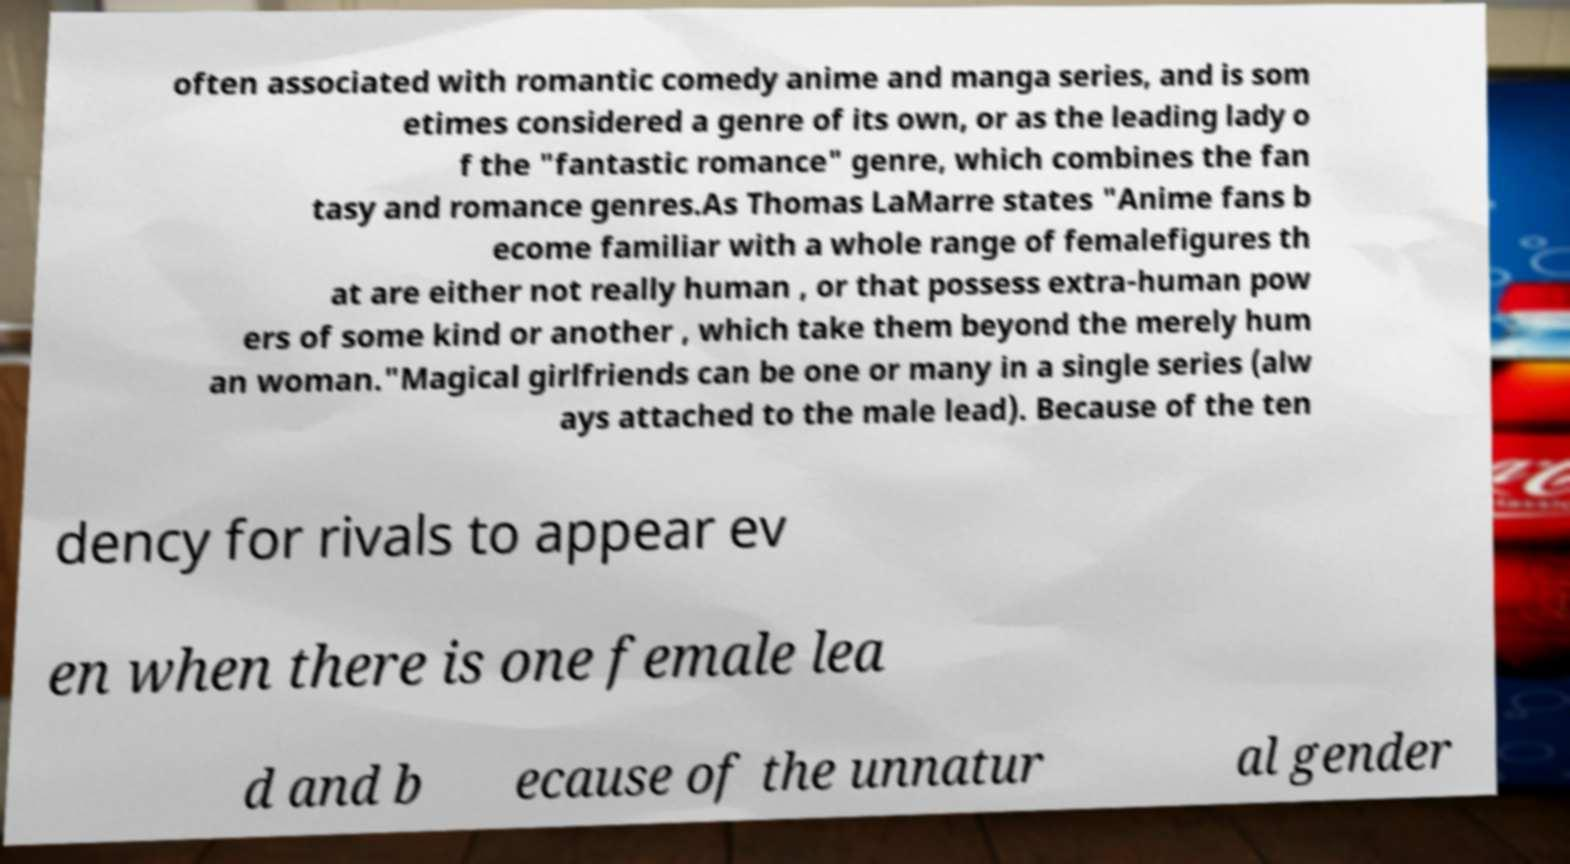Can you accurately transcribe the text from the provided image for me? often associated with romantic comedy anime and manga series, and is som etimes considered a genre of its own, or as the leading lady o f the "fantastic romance" genre, which combines the fan tasy and romance genres.As Thomas LaMarre states "Anime fans b ecome familiar with a whole range of femalefigures th at are either not really human , or that possess extra-human pow ers of some kind or another , which take them beyond the merely hum an woman."Magical girlfriends can be one or many in a single series (alw ays attached to the male lead). Because of the ten dency for rivals to appear ev en when there is one female lea d and b ecause of the unnatur al gender 